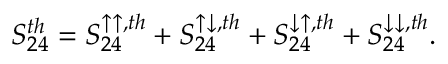Convert formula to latex. <formula><loc_0><loc_0><loc_500><loc_500>{ S _ { 2 4 } ^ { t h } = S _ { 2 4 } ^ { \uparrow \uparrow , t h } + S _ { 2 4 } ^ { \uparrow \downarrow , t h } + S _ { 2 4 } ^ { \downarrow \uparrow , t h } + S _ { 2 4 } ^ { \downarrow \downarrow , t h } } .</formula> 